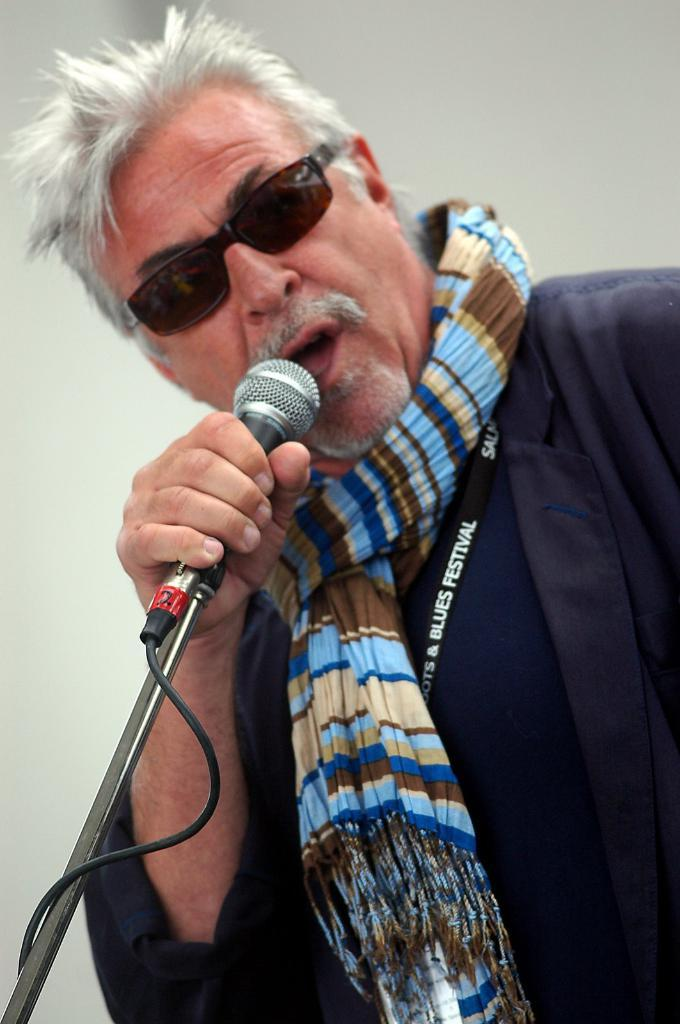What is the main subject of the image? The main subject of the image is a man. What is the man doing in the image? The man is singing in the image. What object is the man holding in his hand? The man is holding a mic in his hand. What type of poison is the man using to enhance his singing in the image? There is no poison present in the image, and the man is not using any substance to enhance his singing. 